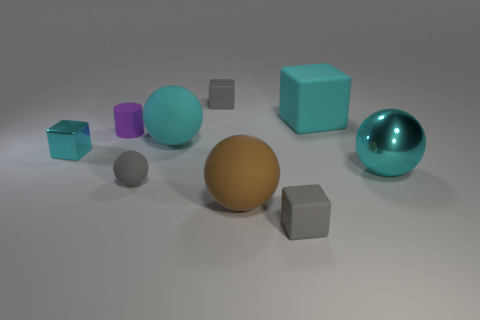Subtract 1 blocks. How many blocks are left? 3 Subtract all blue spheres. Subtract all yellow cylinders. How many spheres are left? 4 Add 1 brown matte objects. How many objects exist? 10 Subtract all balls. How many objects are left? 5 Add 3 large rubber blocks. How many large rubber blocks are left? 4 Add 9 purple cylinders. How many purple cylinders exist? 10 Subtract 0 red cubes. How many objects are left? 9 Subtract all large red metal things. Subtract all big rubber objects. How many objects are left? 6 